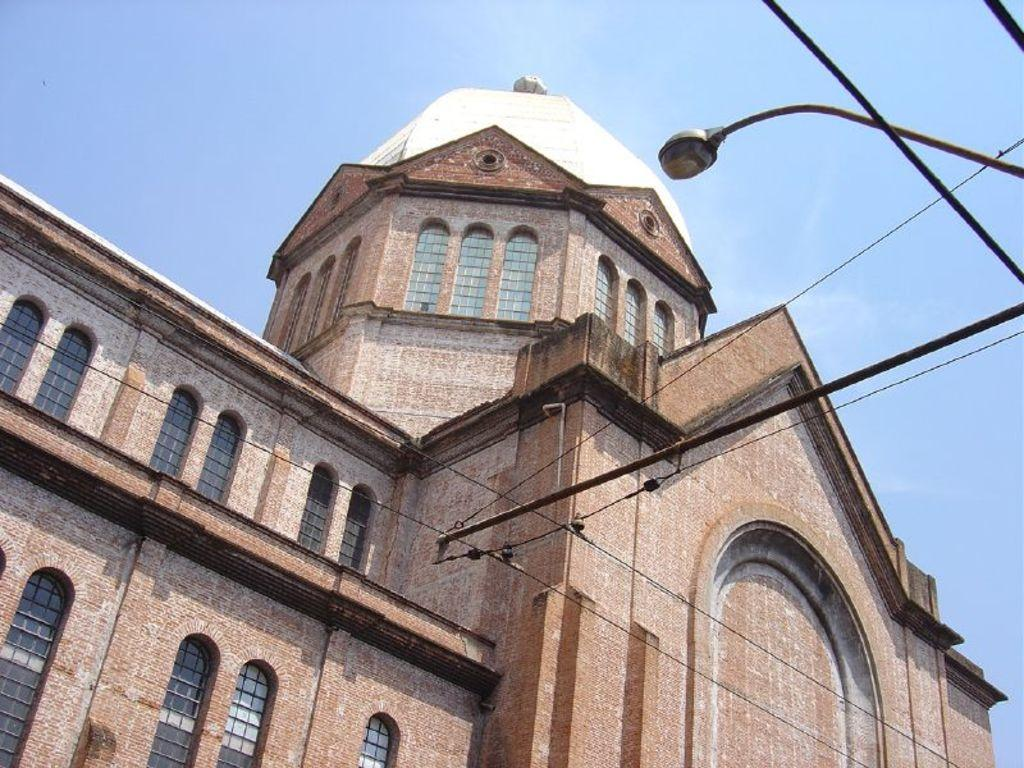What type of structure can be seen in the image? There is a building in the image. What else is visible in the image besides the building? Cables, a light, and metal rods are present in the image. What type of garden can be seen in the image? There is no garden present in the image. What type of clouds can be seen in the image? There is no mention of clouds in the provided facts, and therefore we cannot determine if any are present in the image. 